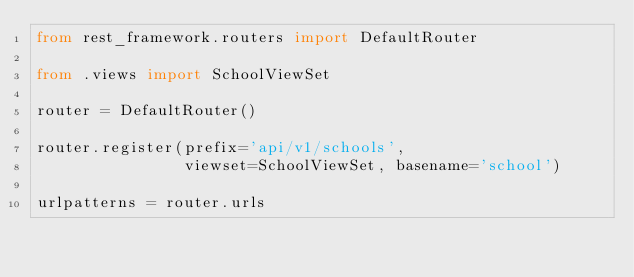Convert code to text. <code><loc_0><loc_0><loc_500><loc_500><_Python_>from rest_framework.routers import DefaultRouter

from .views import SchoolViewSet

router = DefaultRouter()

router.register(prefix='api/v1/schools',
                viewset=SchoolViewSet, basename='school')

urlpatterns = router.urls
</code> 